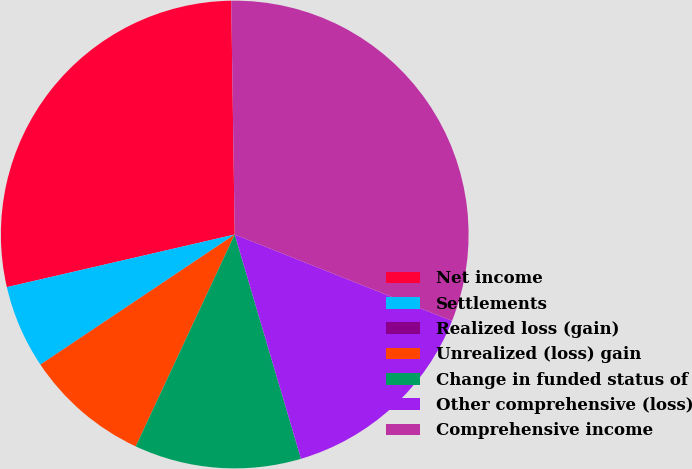Convert chart to OTSL. <chart><loc_0><loc_0><loc_500><loc_500><pie_chart><fcel>Net income<fcel>Settlements<fcel>Realized loss (gain)<fcel>Unrealized (loss) gain<fcel>Change in funded status of<fcel>Other comprehensive (loss)<fcel>Comprehensive income<nl><fcel>28.38%<fcel>5.77%<fcel>0.01%<fcel>8.65%<fcel>11.53%<fcel>14.41%<fcel>31.26%<nl></chart> 